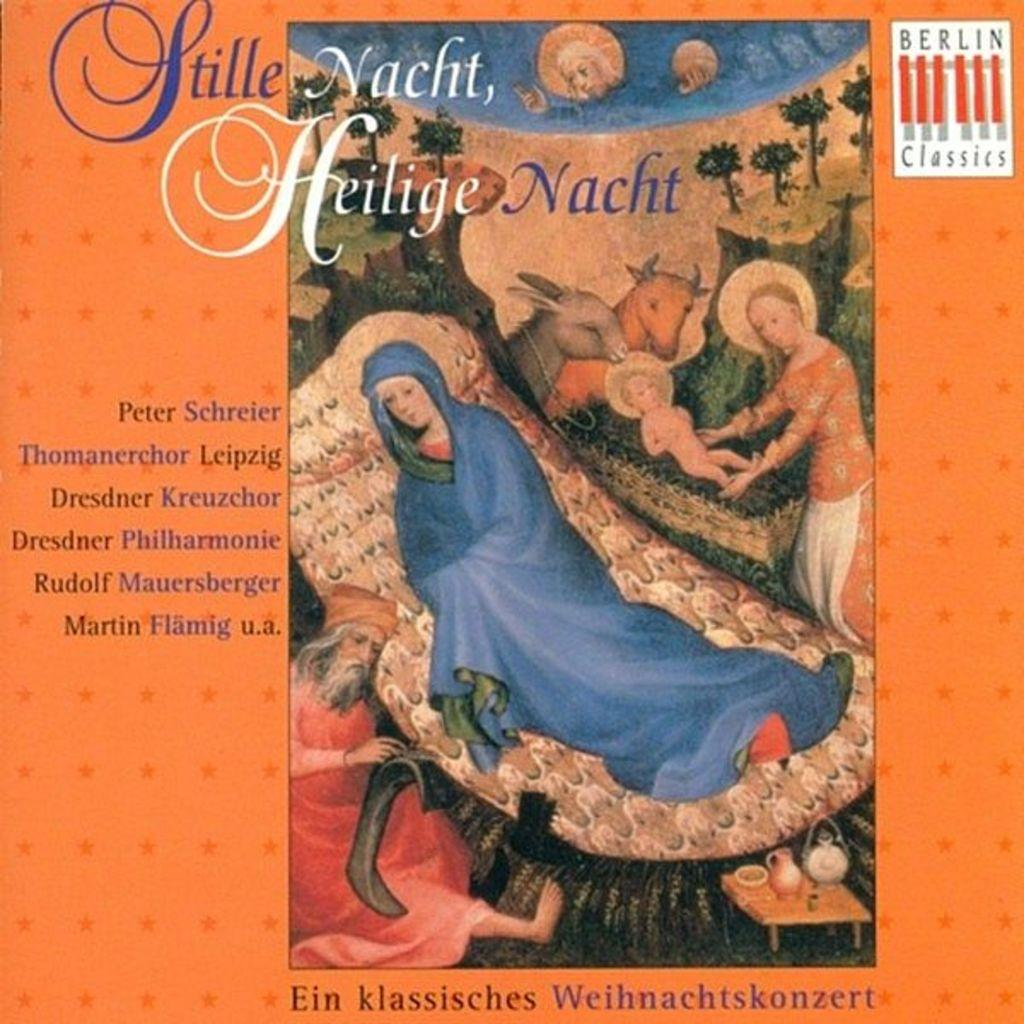<image>
Render a clear and concise summary of the photo. An advertisement with a woman in a blue robe has the logo for Berlin Classics in the right corner. 